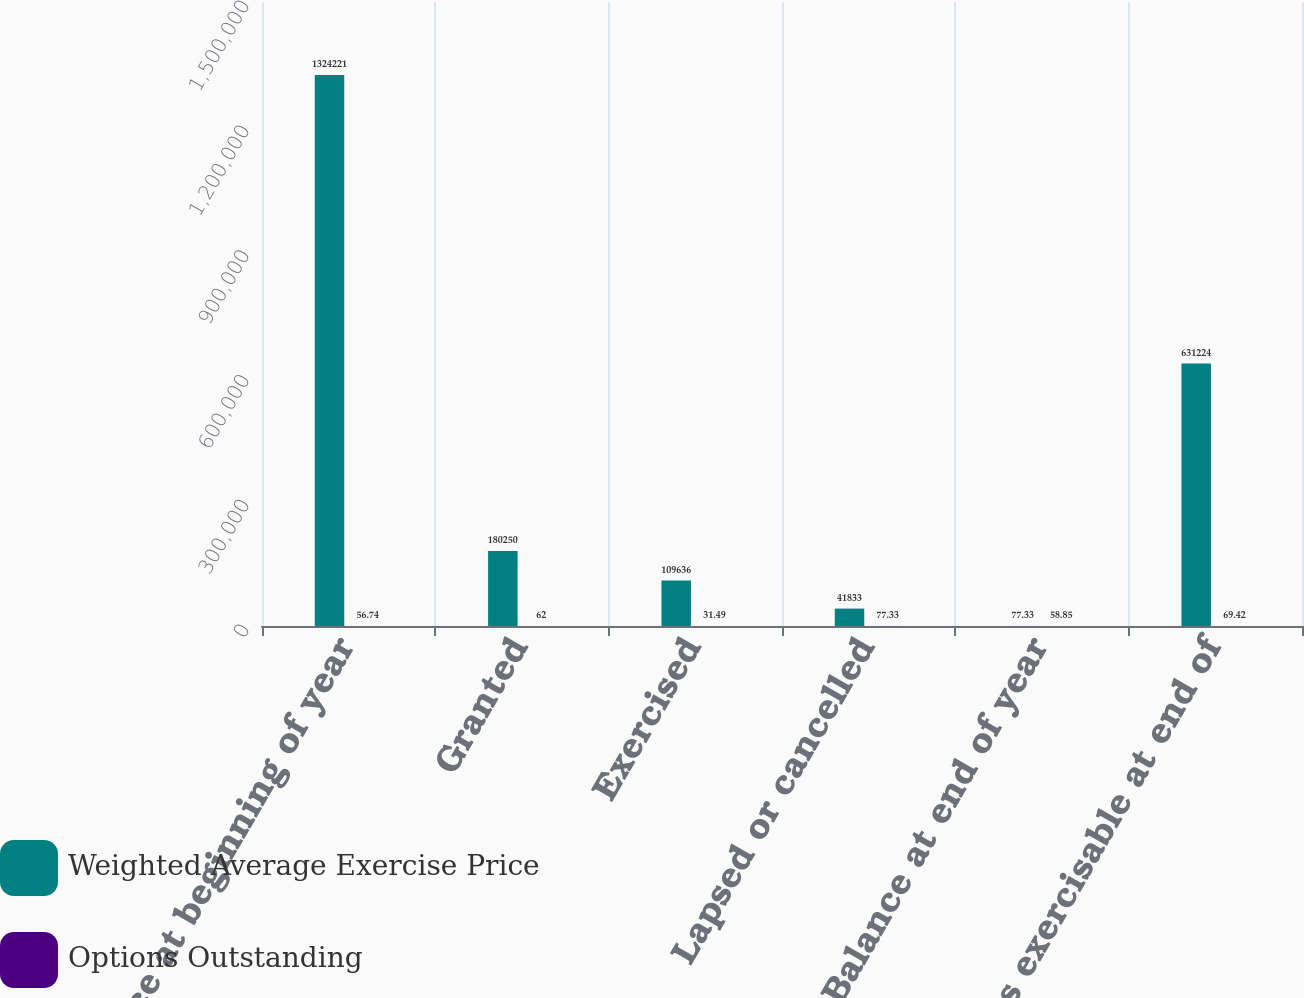Convert chart. <chart><loc_0><loc_0><loc_500><loc_500><stacked_bar_chart><ecel><fcel>Balance at beginning of year<fcel>Granted<fcel>Exercised<fcel>Lapsed or cancelled<fcel>Balance at end of year<fcel>Options exercisable at end of<nl><fcel>Weighted Average Exercise Price<fcel>1.32422e+06<fcel>180250<fcel>109636<fcel>41833<fcel>77.33<fcel>631224<nl><fcel>Options Outstanding<fcel>56.74<fcel>62<fcel>31.49<fcel>77.33<fcel>58.85<fcel>69.42<nl></chart> 